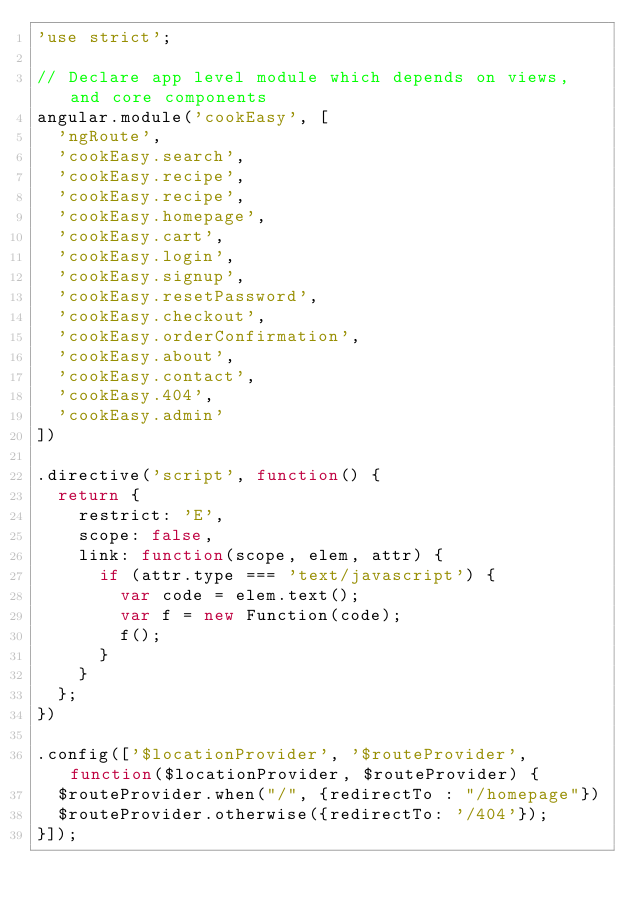<code> <loc_0><loc_0><loc_500><loc_500><_JavaScript_>'use strict';

// Declare app level module which depends on views, and core components
angular.module('cookEasy', [
  'ngRoute',
  'cookEasy.search',
  'cookEasy.recipe',
  'cookEasy.recipe',
  'cookEasy.homepage',
  'cookEasy.cart',
  'cookEasy.login',
  'cookEasy.signup',
  'cookEasy.resetPassword',
  'cookEasy.checkout',
  'cookEasy.orderConfirmation',
  'cookEasy.about',
  'cookEasy.contact',
  'cookEasy.404',
  'cookEasy.admin'
])

.directive('script', function() {
  return {
    restrict: 'E',
    scope: false,
    link: function(scope, elem, attr) {
      if (attr.type === 'text/javascript') {
        var code = elem.text();
        var f = new Function(code);
        f();
      }
    }
  };
})

.config(['$locationProvider', '$routeProvider', function($locationProvider, $routeProvider) {
  $routeProvider.when("/", {redirectTo : "/homepage"})
  $routeProvider.otherwise({redirectTo: '/404'});
}]);
</code> 